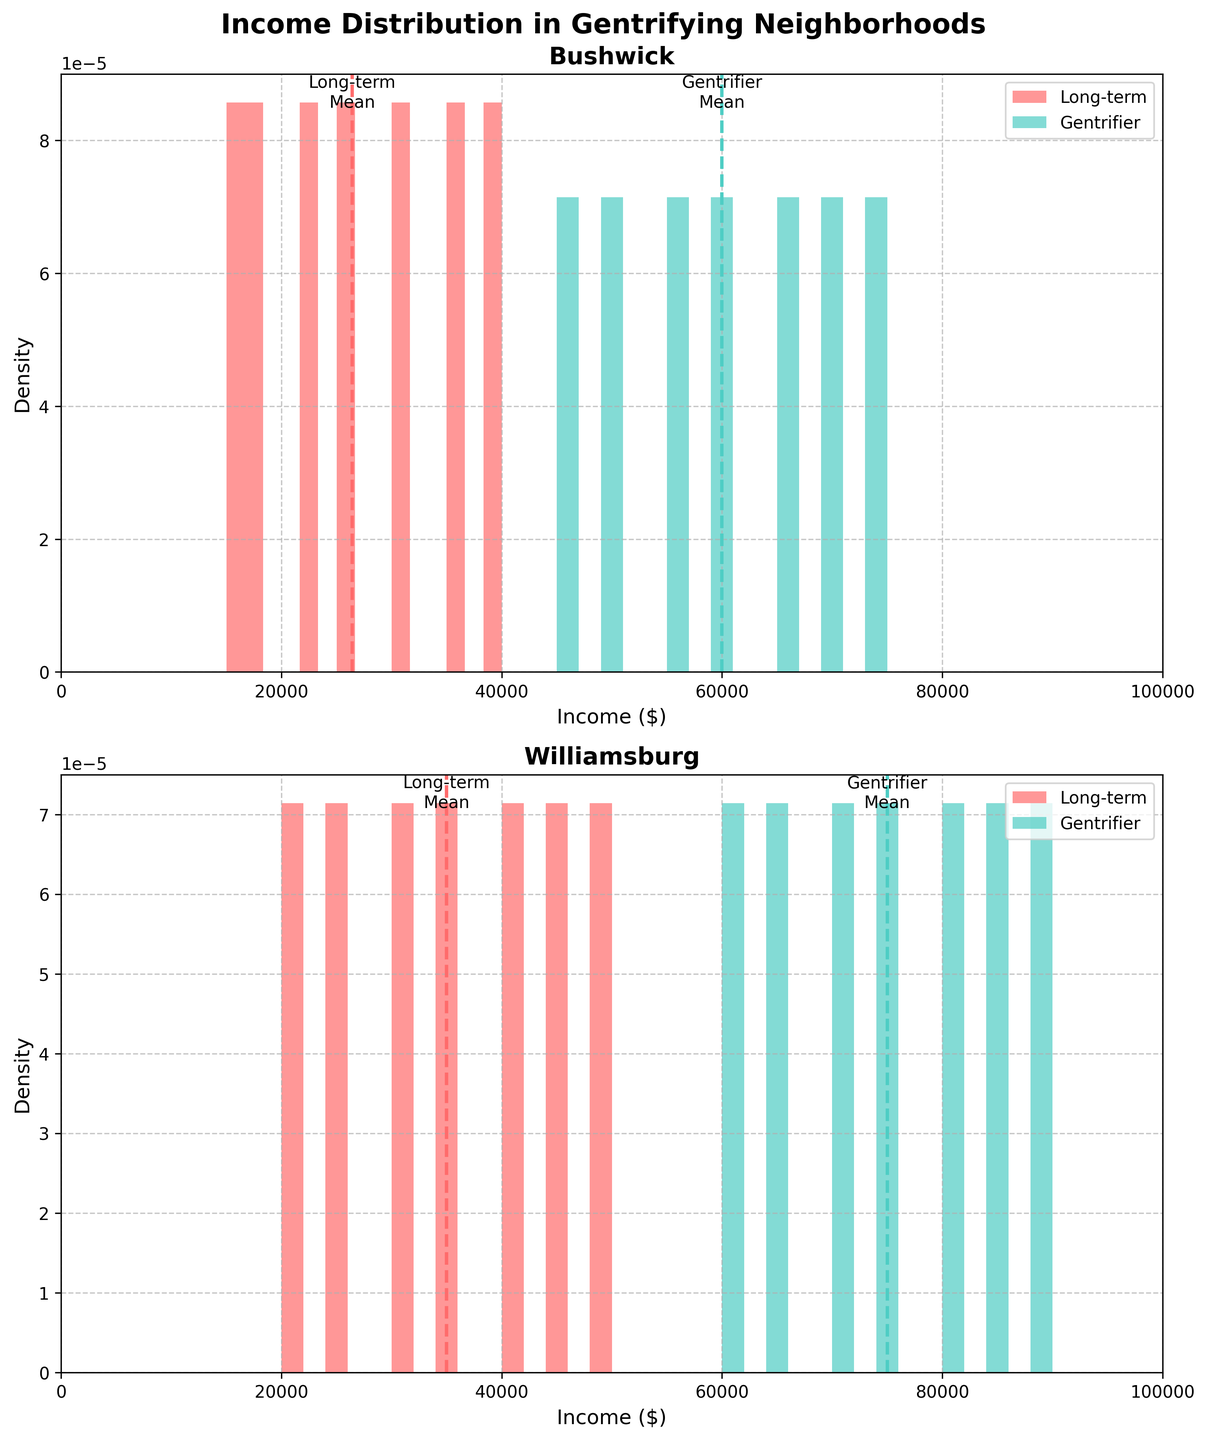What's the title of the figure? The title of the figure is displayed at the top and gives an overview of the data being visualized.
Answer: Income Distribution in Gentrifying Neighborhoods Which neighborhood shows a higher average income for 'Gentrifier' residents? To find this, compare the mean income lines for 'Gentrifier' residents in both neighborhoods. The figure labels these means, making it easier to identify. The 'Gentrifier' mean income in Williamsburg is higher than in Bushwick.
Answer: Williamsburg How many distinct colors are used in each subplot, and what do they represent? Each subplot uses two distinct colors to differentiate between 'Long-term' and 'Gentrifier' residents. In this figure, one color represents 'Long-term' residents and another represents 'Gentrifier' residents; these can be visually distinguished from the histogram bars.
Answer: Two colors, representing 'Long-term' and 'Gentrifier' residents In Williamsburg, which resident type has their income distribution more spread out? Look at the income distribution width in Williamsburg for both resident types. The 'Gentrifier' histogram bars spread across a wider range compared to 'Long-term' residents.
Answer: Gentrifier residents What is the mean income for 'Long-term' residents in Bushwick? Examine the vertical line indicating the mean income for 'Long-term' residents within the Bushwick subplot. This line is marked with a label denoting the mean.
Answer: $30,000 Is the income distribution of 'Long-term' residents higher or lower in Bushwick compared to Williamsburg? Check the positions of the income histogram bars for 'Long-term' residents in each subplot. Bushwick's are generally lower (between $15,000 and $40,000) compared to Williamsburg (between $20,000 and $50,000).
Answer: Lower in Bushwick In which neighborhood is the income gap between 'Gentrifier' and 'Long-term' residents more pronounced? Assess how far the mean income lines for 'Gentrifier' and 'Long-term' residents are from each other in each neighborhood. The gap in Williamsburg (from $35,000 to $75,000) is larger compared to Bushwick (from $30,000 to $60,000).
Answer: Williamsburg What is the lowest income value depicted in both subplots? The lowest income value visible in both subplots is indicated by the starting point of the histogram bars. Both neighborhood histograms start at $15,000.
Answer: $15,000 Are the income distributions for 'Long-term' and 'Gentrifier' residents overlapped in any neighborhood? By observing the histograms, determine if there is any overlap in the income ranges for 'Long-term' and 'Gentrifier' residents. There is minimal overlap in Bushwick, whereas in Williamsburg the distributions are more separate.
Answer: Yes, minimal overlap in Bushwick For 'Gentrifier' residents in Bushwick, which income range shows the highest density? The highest density for 'Gentrifier' residents is observed from the peak of the histogram bars within the Bushwick subplot. The peak for 'Gentrifier' in Bushwick appears around $45,000 to $50,000.
Answer: $45,000-$50,000 